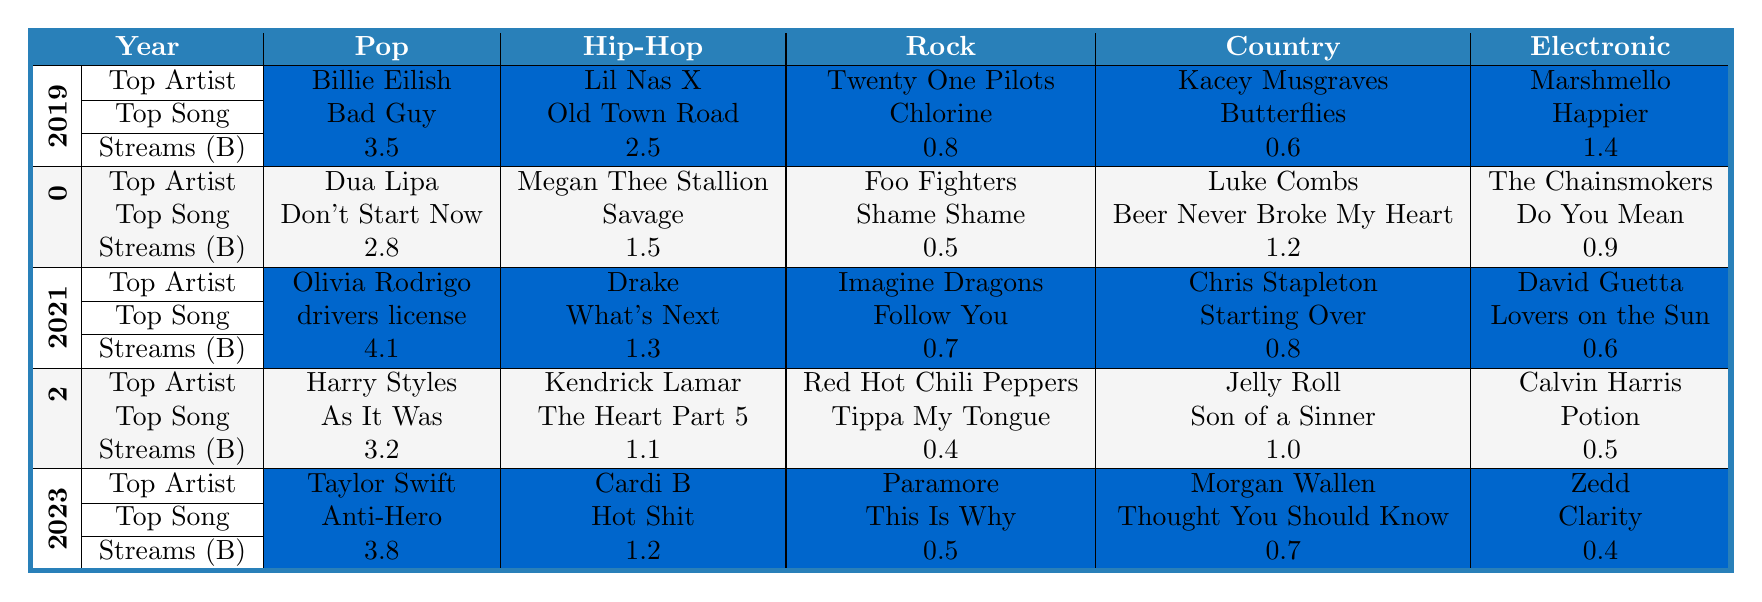What's the top song in Pop for 2021? In the table, under the year 2021 in the Pop category, the top song is listed as "drivers license."
Answer: drivers license Who is the top artist in Electronic music for 2020? The top artist in the Electronic category for the year 2020 is "The Chainsmokers," as indicated in the table.
Answer: The Chainsmokers What genre had the highest streams in 2021? In 2021, Pop had the highest streams with a total of 4.1 billion, compared to other genres like Hip-Hop with 1.3 billion and Rock with 0.7 billion.
Answer: Pop In which year did Country music see the highest total streams? To find the year with the highest streams for Country music, we look at the values: 0.6 billion in 2019, 1.2 billion in 2020, 0.8 billion in 2021, 1.0 billion in 2022, and 0.7 billion in 2023. The highest is in 2020 with 1.2 billion.
Answer: 2020 Was there a decrease in streams for Hip-Hop from 2019 to 2023? Checking the streams for Hip-Hop: 2.5 billion in 2019, 1.5 billion in 2020, 1.3 billion in 2021, 1.1 billion in 2022, and 1.2 billion in 2023, shows a decrease from 2019 to 2022, but an increase from 2022 to 2023. Hence, overall it decreased, but 2023 saw a slight increase from 2022.
Answer: Yes, overall there was a decrease Which years had a top artist in Pop with streams above 3 billion? Examining the streams in the Pop category: 2019 had 3.5 billion, 2021 had 4.1 billion, and 2023 had 3.8 billion. Therefore, the years are 2019, 2021, and 2023.
Answer: 2019, 2021, and 2023 What is the average number of streams for Rock in 2022 and 2023? For Rock, the streams in 2022 are 0.4 billion and in 2023 are 0.5 billion. Adding these together gives 0.9 billion, and dividing by 2 for the average results in 0.45 billion.
Answer: 0.45 billion Which genre had the lowest streams in 2022? In 2022, the streams for each genre were: Pop (3.2 billion), Hip-Hop (1.1 billion), Rock (0.4 billion), Country (1.0 billion), and Electronic (0.5 billion). The lowest was Rock with 0.4 billion.
Answer: Rock Was there a top song in Country music that had more streams than the top song in Rock for 2020? For 2020, the top song in Country, "Beer Never Broke My Heart," had 1.2 billion streams while the top song in Rock, "Shame Shame," had 0.5 billion streams. Therefore, the Country song had higher streams.
Answer: Yes What genre has consistently shown the lowest streams across all years? Reviewing the streams for each genre across all years reveals: Rock generally has lower streams than the others, with values of 0.8 (2019), 0.5 (2020), 0.7 (2021), 0.4 (2022), and 0.5 (2023). Therefore, Rock has consistently shown the lowest streams.
Answer: Rock 